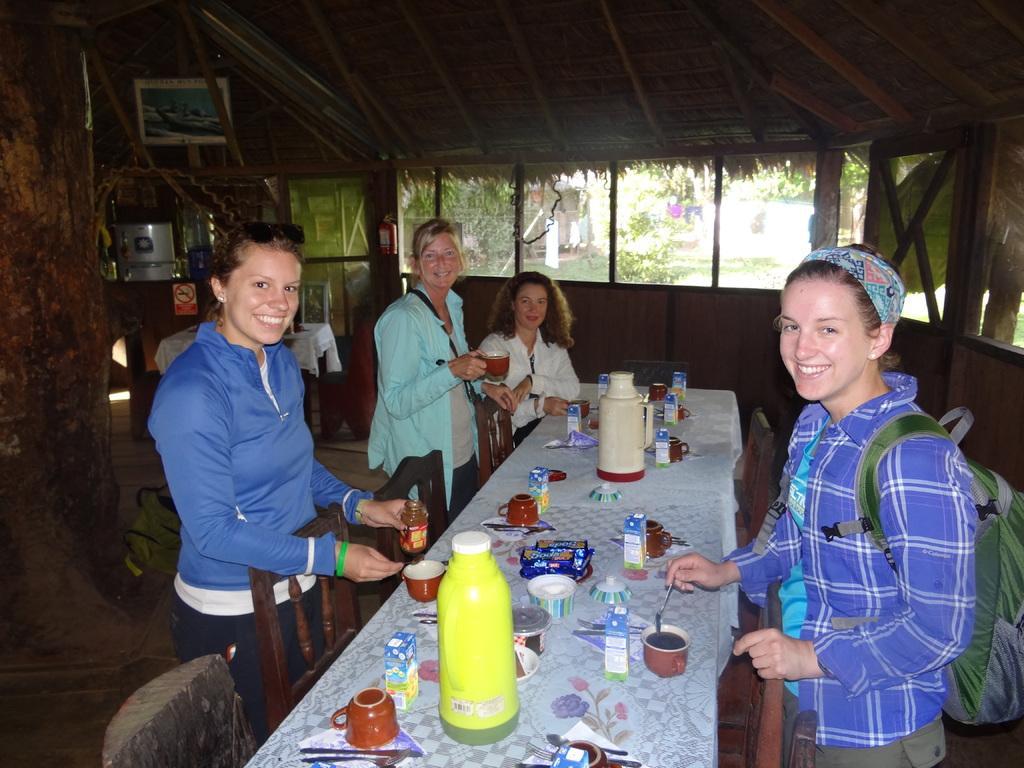In one or two sentences, can you explain what this image depicts? In this Image I see 4 women in which 3 of them are standing and this woman is sitting, I can also see that all of them are smiling. I see that this 2 are holding a thing in their hands and I see that there are chairs and table on which there are lot of things. In the background I see the windows and the ceiling. 